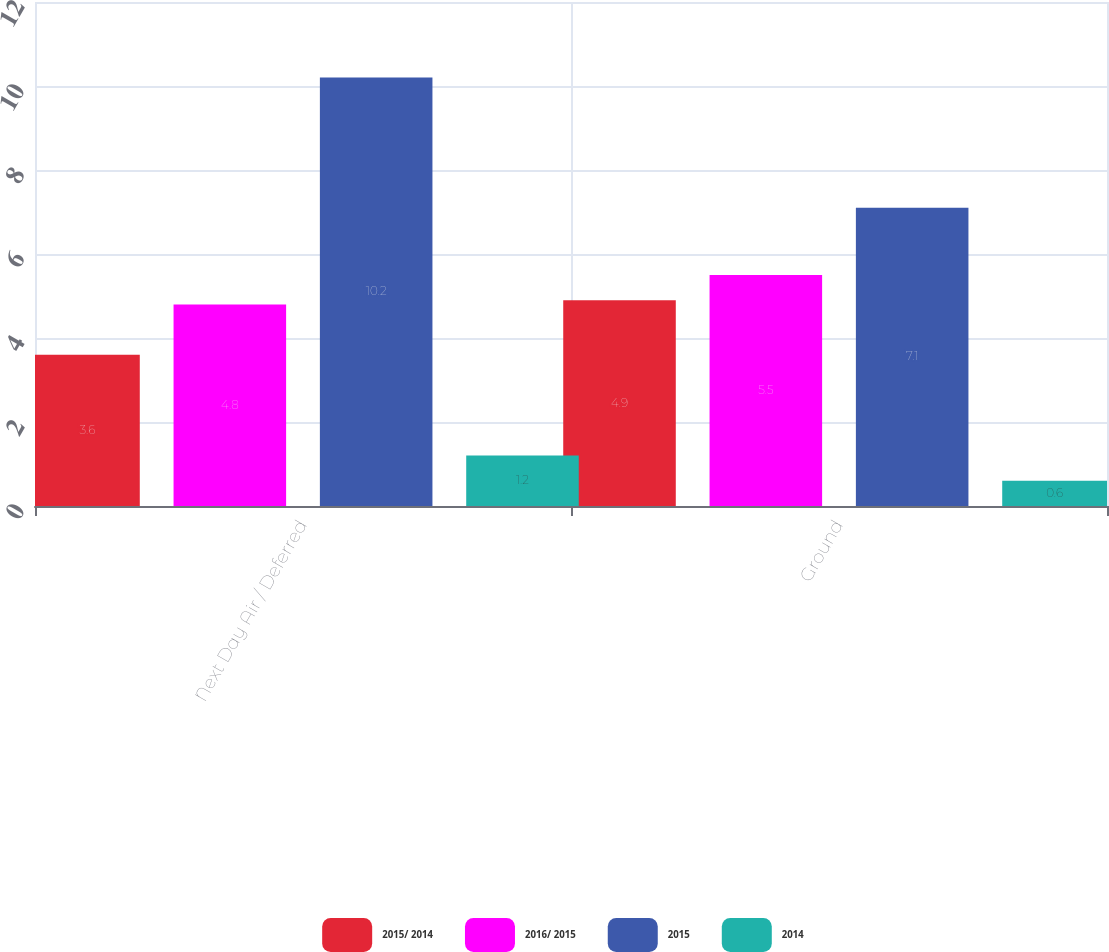Convert chart to OTSL. <chart><loc_0><loc_0><loc_500><loc_500><stacked_bar_chart><ecel><fcel>Next Day Air / Deferred<fcel>Ground<nl><fcel>2015/ 2014<fcel>3.6<fcel>4.9<nl><fcel>2016/ 2015<fcel>4.8<fcel>5.5<nl><fcel>2015<fcel>10.2<fcel>7.1<nl><fcel>2014<fcel>1.2<fcel>0.6<nl></chart> 